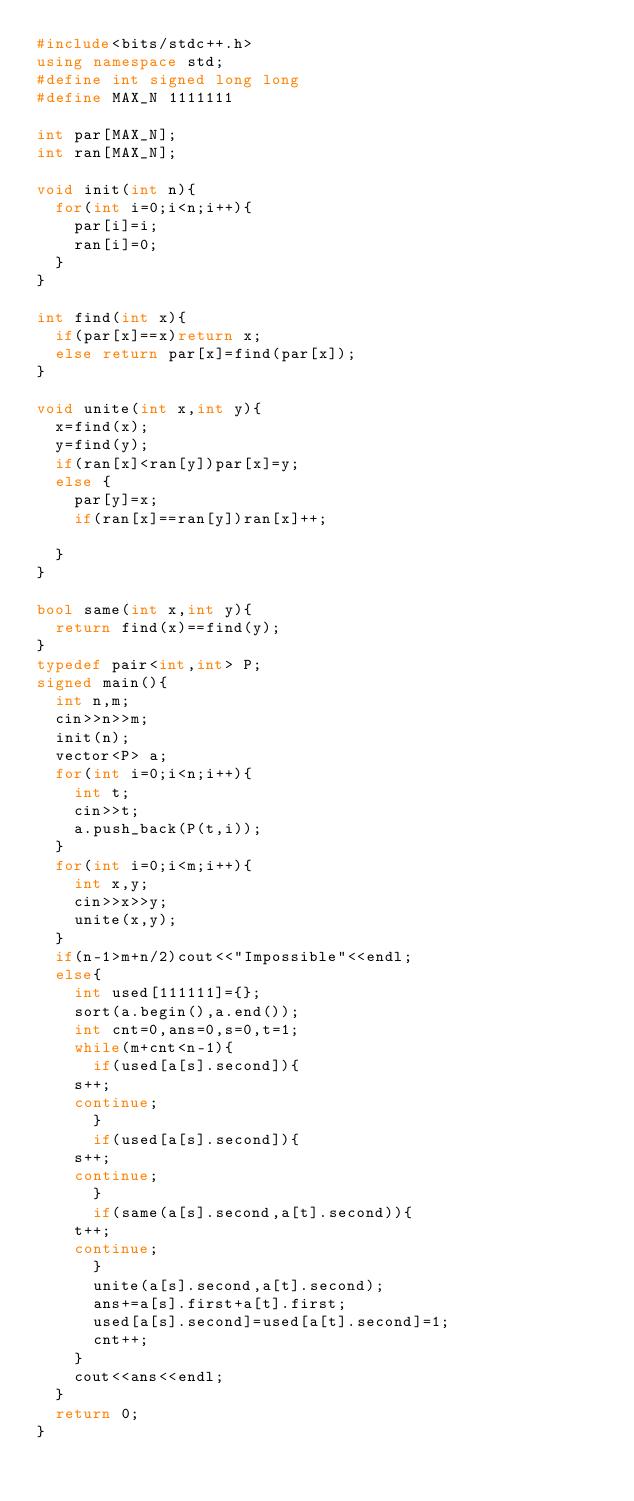<code> <loc_0><loc_0><loc_500><loc_500><_C++_>#include<bits/stdc++.h>
using namespace std;
#define int signed long long
#define MAX_N 1111111

int par[MAX_N]; 
int ran[MAX_N]; 

void init(int n){
  for(int i=0;i<n;i++){
    par[i]=i;
    ran[i]=0;
  }
}

int find(int x){
  if(par[x]==x)return x;
  else return par[x]=find(par[x]);
}

void unite(int x,int y){
  x=find(x);
  y=find(y);
  if(ran[x]<ran[y])par[x]=y;
  else {
    par[y]=x;
    if(ran[x]==ran[y])ran[x]++;

  }
}

bool same(int x,int y){
  return find(x)==find(y);
}
typedef pair<int,int> P;
signed main(){
  int n,m;
  cin>>n>>m;
  init(n);
  vector<P> a;
  for(int i=0;i<n;i++){
    int t;
    cin>>t;
    a.push_back(P(t,i));
  }
  for(int i=0;i<m;i++){
    int x,y;
    cin>>x>>y;
    unite(x,y);
  }
  if(n-1>m+n/2)cout<<"Impossible"<<endl;
  else{
    int used[111111]={};
    sort(a.begin(),a.end());
    int cnt=0,ans=0,s=0,t=1;
    while(m+cnt<n-1){
      if(used[a[s].second]){
	s++;
	continue;
      }
      if(used[a[s].second]){
	s++;
	continue;
      }
      if(same(a[s].second,a[t].second)){
	t++;
	continue;
      }
      unite(a[s].second,a[t].second);
      ans+=a[s].first+a[t].first;
      used[a[s].second]=used[a[t].second]=1;
      cnt++;
    }
    cout<<ans<<endl;
  }
  return 0;
}
</code> 